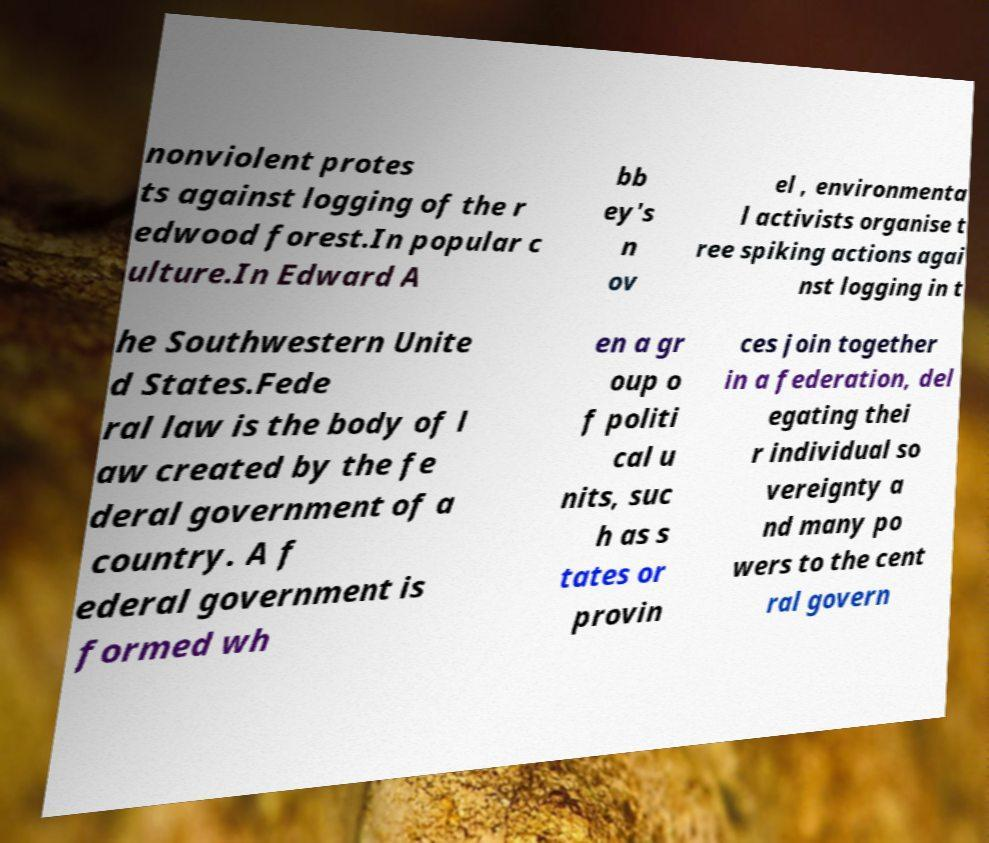Can you read and provide the text displayed in the image?This photo seems to have some interesting text. Can you extract and type it out for me? nonviolent protes ts against logging of the r edwood forest.In popular c ulture.In Edward A bb ey's n ov el , environmenta l activists organise t ree spiking actions agai nst logging in t he Southwestern Unite d States.Fede ral law is the body of l aw created by the fe deral government of a country. A f ederal government is formed wh en a gr oup o f politi cal u nits, suc h as s tates or provin ces join together in a federation, del egating thei r individual so vereignty a nd many po wers to the cent ral govern 